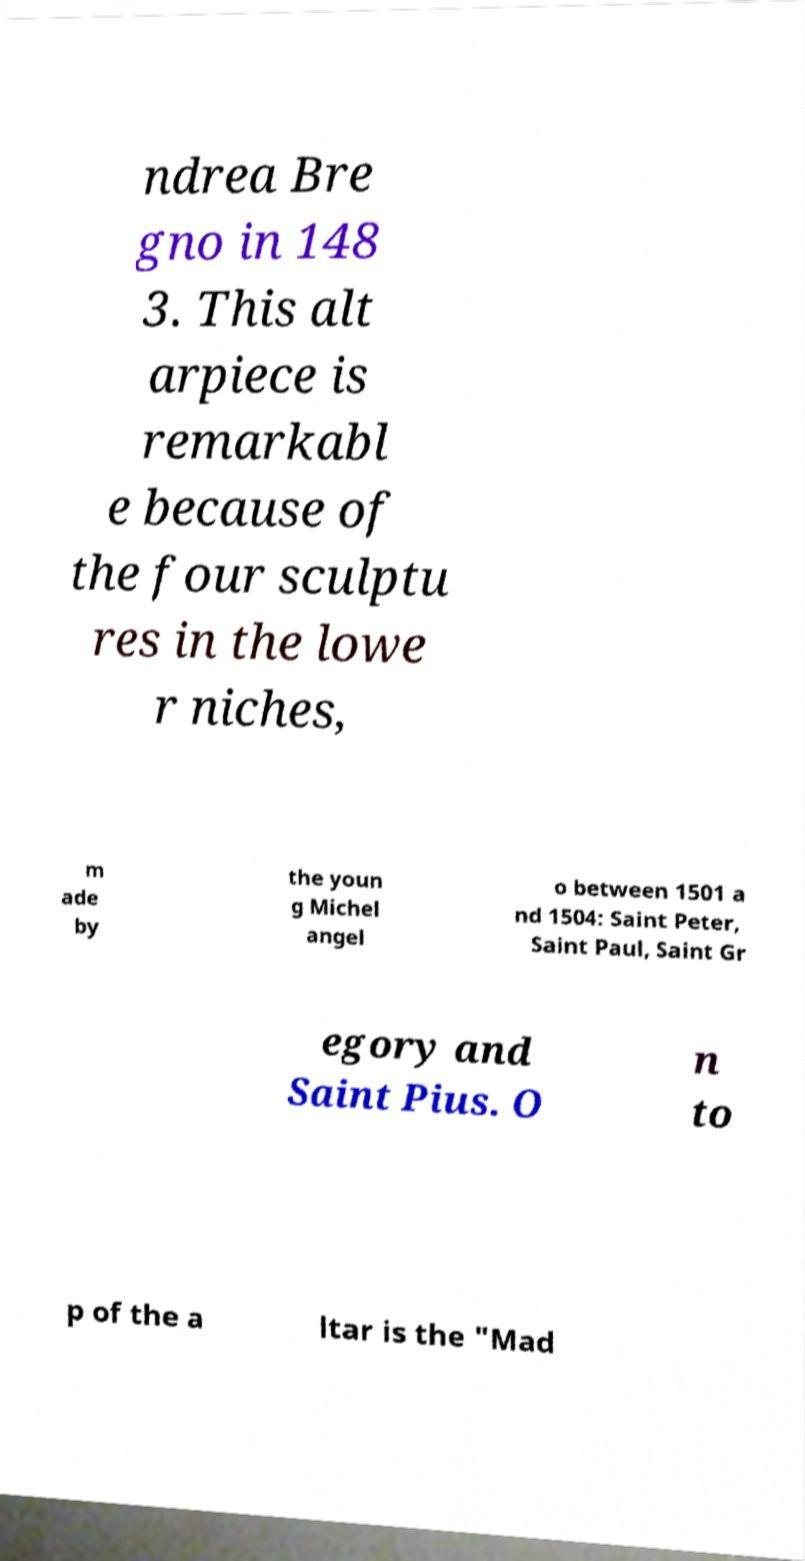Can you read and provide the text displayed in the image?This photo seems to have some interesting text. Can you extract and type it out for me? ndrea Bre gno in 148 3. This alt arpiece is remarkabl e because of the four sculptu res in the lowe r niches, m ade by the youn g Michel angel o between 1501 a nd 1504: Saint Peter, Saint Paul, Saint Gr egory and Saint Pius. O n to p of the a ltar is the "Mad 